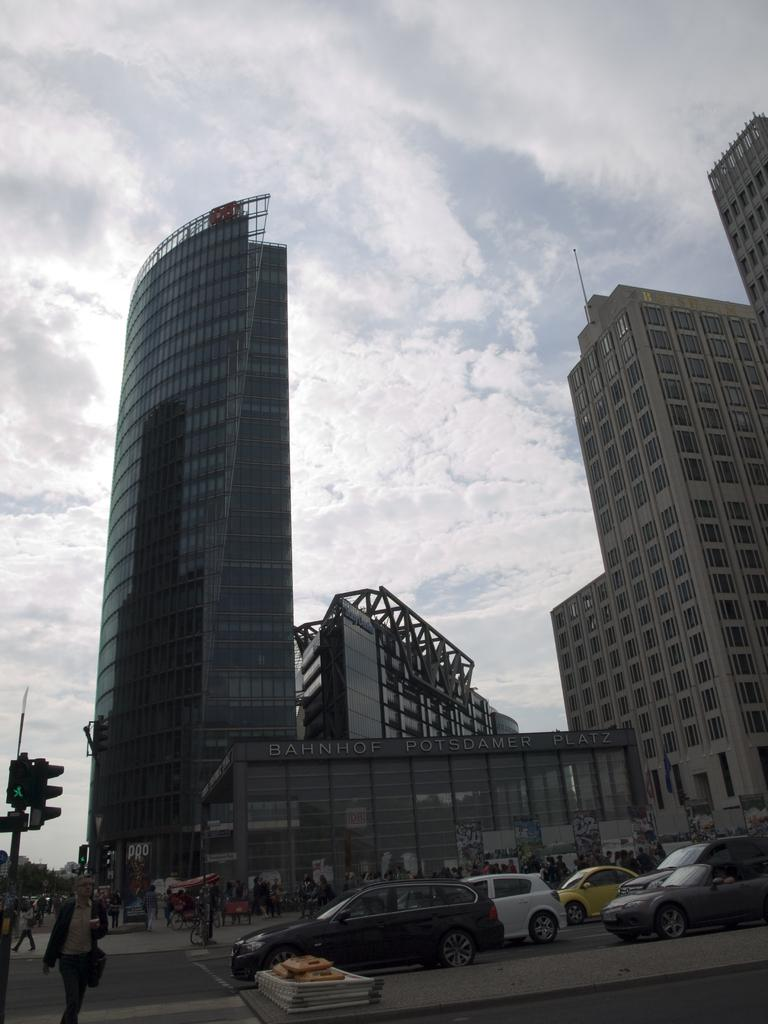What type of structures can be seen in the image? There are buildings in the image. Are there any people visible in the image? Yes, there are persons in the image. What mode of transportation can be seen on the road in the image? Motor vehicles are present on the road in the image. What type of information might be conveyed by the signs in the image? The signs in the image might convey information about directions, warnings, or advertisements. What part of the natural environment is visible in the image? The sky is visible in the image. What type of weather can be inferred from the clouds in the sky? The presence of clouds suggests that the weather might be overcast or cloudy. Can you see any ghosts interacting with the persons in the image? There are no ghosts present in the image. What type of appliance is being used by the persons in the image? There is no appliance visible in the image; it only shows buildings, persons, motor vehicles, signs, and the sky. Are there any pears visible in the image? There are no pears present in the image. 